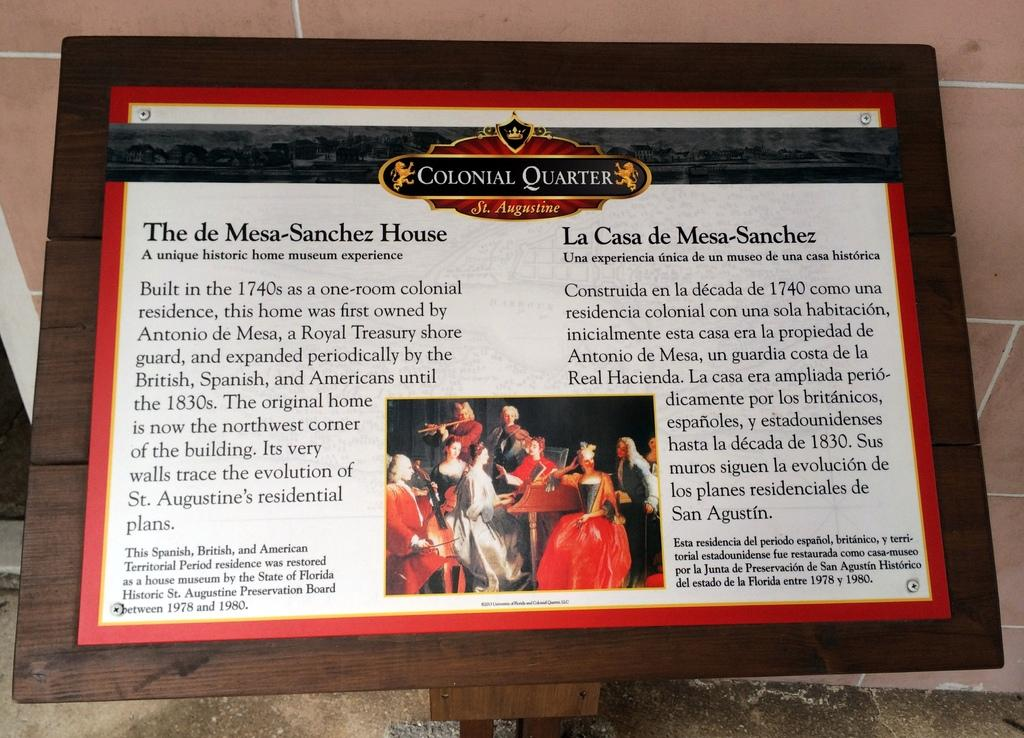<image>
Render a clear and concise summary of the photo. A sign tells the history of the Mesa-Sanchez house in both English and Spanish. 